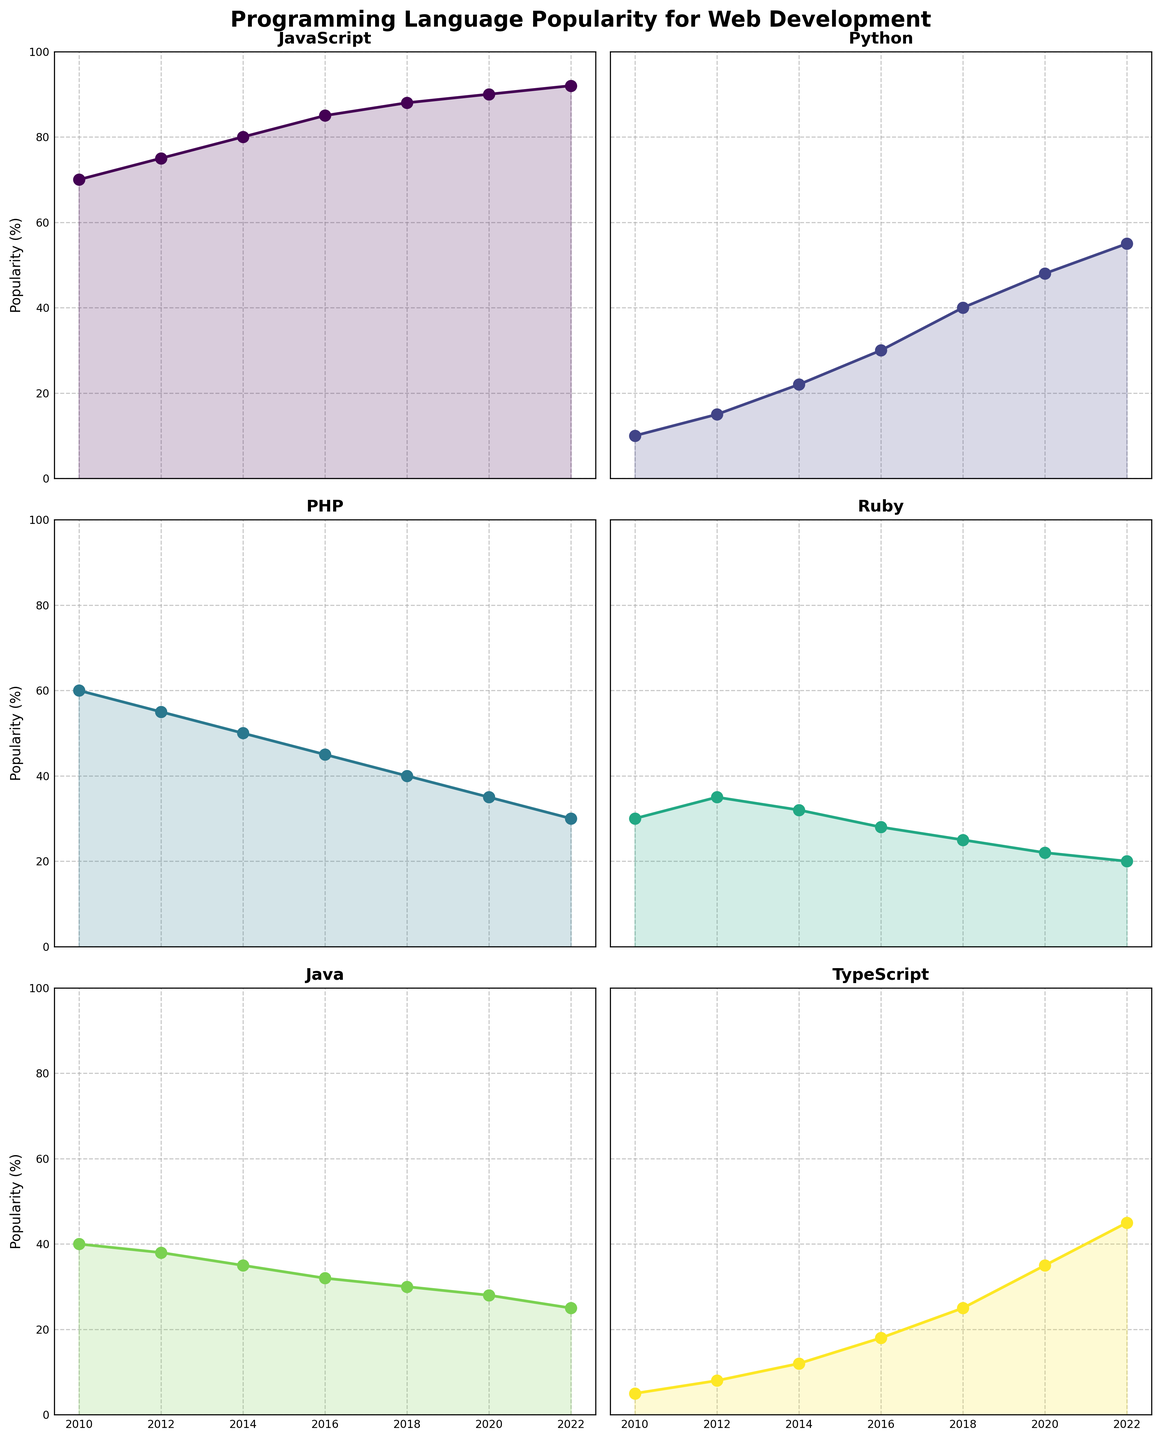What is the overall trend for JavaScript's popularity over the years? JavaScript's popularity shows a consistent increase from 70% in 2010 to 92% in 2022. Each data point is higher than the previous one, indicating a steady upward trend.
Answer: Steady increase When did Python see the most significant rise in popularity? By examining the plots, we see that Python's biggest jump in popularity occurred between 2016 and 2018, where it increased from 30% to 40%. This 10% increase is the largest compared to other intervals.
Answer: 2016-2018 Which programming language had the least popularity in 2010? In the 2010 subplot, TypeScript shows the lowest popularity percentage at 5%.
Answer: TypeScript How did PHP's popularity change from 2014 to 2022? PHP's popularity decreased from 50% in 2014 to 30% in 2022. This is a consistent decline over the years.
Answer: Decreased Which year did Java's popularity fall below 30%? Java's popularity dropped below 30% in 2018, where it reached 28%.
Answer: 2018 What is the average popularity of Ruby across all years presented? Adding Ruby's values: 30 (2010) + 35 (2012) + 32 (2014) + 28 (2016) + 25 (2018) + 22 (2020) + 20 (2022) and dividing by the number of years (7) gives us (30+35+32+28+25+22+20)/7 = 27.4%.
Answer: 27.4% Which language had the closest popularity to each other in 2016? By comparing 2016 data, PHP (45%) and Python (30%) seem closest, but JavaScript (85%) and Python (30%) have a much closer difference of 55%, compared to PHP's closer but small 15%. Therefore, JavaScript and Python are closer when considering percentage difference.
Answer: JavaScript and Python In which year did TypeScript surpass Java in popularity? By observing the plots, TypeScript surpassed Java in 2022, where TypeScript had a popularity of 45% compared to Java's 25%.
Answer: 2022 What is the steepest decline observed in PHP's popularity? PHP's popularity drops steeply from 45% in 2016 to 40% in 2018, a 5% decline in two years. While not extremely steep compared to other languages, it is PHP's largest drop.
Answer: 2016-2018 Which programming language had the highest peak in popularity across all years? JavaScript stands out with the highest peak at 92% in 2022. No other languages come close to this peak.
Answer: JavaScript 